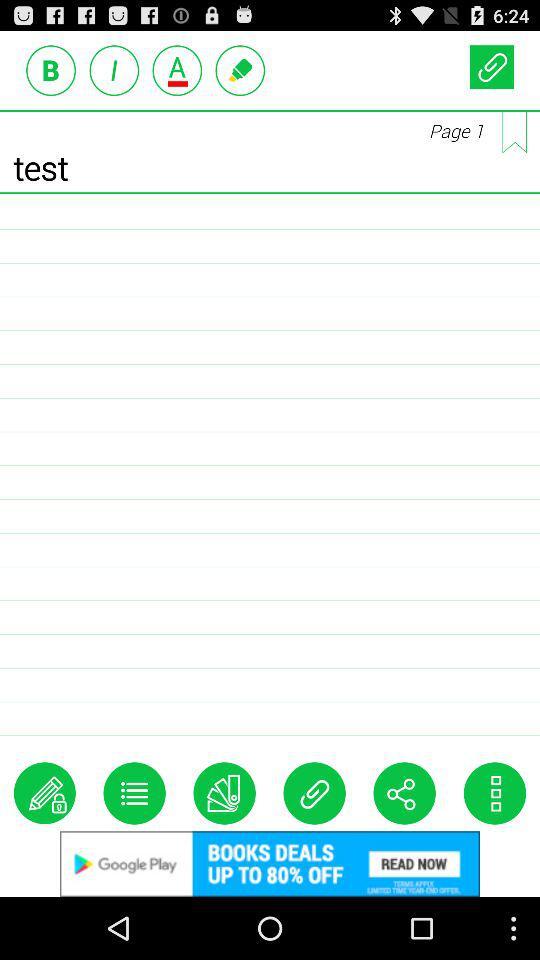At what page am I? You are at page 1. 